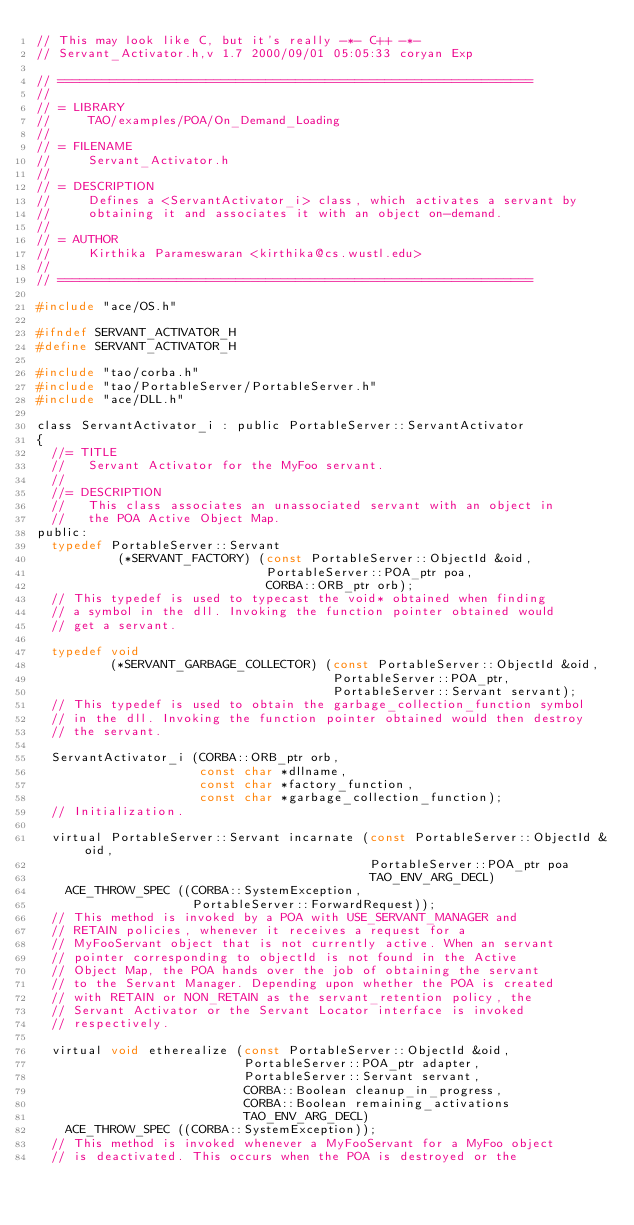Convert code to text. <code><loc_0><loc_0><loc_500><loc_500><_C_>// This may look like C, but it's really -*- C++ -*-
// Servant_Activator.h,v 1.7 2000/09/01 05:05:33 coryan Exp

// ================================================================
//
// = LIBRARY
//     TAO/examples/POA/On_Demand_Loading
//
// = FILENAME
//     Servant_Activator.h
//
// = DESCRIPTION
//     Defines a <ServantActivator_i> class, which activates a servant by
//     obtaining it and associates it with an object on-demand.
//
// = AUTHOR
//     Kirthika Parameswaran <kirthika@cs.wustl.edu>
//
// ================================================================

#include "ace/OS.h"

#ifndef SERVANT_ACTIVATOR_H
#define SERVANT_ACTIVATOR_H

#include "tao/corba.h"
#include "tao/PortableServer/PortableServer.h"
#include "ace/DLL.h"

class ServantActivator_i : public PortableServer::ServantActivator
{
  //= TITLE
  //   Servant Activator for the MyFoo servant.
  //
  //= DESCRIPTION
  //   This class associates an unassociated servant with an object in
  //   the POA Active Object Map.
public:
  typedef PortableServer::Servant
           (*SERVANT_FACTORY) (const PortableServer::ObjectId &oid,
                               PortableServer::POA_ptr poa,
                               CORBA::ORB_ptr orb);
  // This typedef is used to typecast the void* obtained when finding
  // a symbol in the dll. Invoking the function pointer obtained would
  // get a servant.

  typedef void
          (*SERVANT_GARBAGE_COLLECTOR) (const PortableServer::ObjectId &oid,
                                        PortableServer::POA_ptr,
                                        PortableServer::Servant servant);
  // This typedef is used to obtain the garbage_collection_function symbol
  // in the dll. Invoking the function pointer obtained would then destroy
  // the servant.

  ServantActivator_i (CORBA::ORB_ptr orb,
                      const char *dllname,
                      const char *factory_function,
                      const char *garbage_collection_function);
  // Initialization.

  virtual PortableServer::Servant incarnate (const PortableServer::ObjectId &oid,
                                             PortableServer::POA_ptr poa
                                             TAO_ENV_ARG_DECL)
    ACE_THROW_SPEC ((CORBA::SystemException,
                     PortableServer::ForwardRequest));
  // This method is invoked by a POA with USE_SERVANT_MANAGER and
  // RETAIN policies, whenever it receives a request for a
  // MyFooServant object that is not currently active. When an servant
  // pointer corresponding to objectId is not found in the Active
  // Object Map, the POA hands over the job of obtaining the servant
  // to the Servant Manager. Depending upon whether the POA is created
  // with RETAIN or NON_RETAIN as the servant_retention policy, the
  // Servant Activator or the Servant Locator interface is invoked
  // respectively.

  virtual void etherealize (const PortableServer::ObjectId &oid,
                            PortableServer::POA_ptr adapter,
                            PortableServer::Servant servant,
                            CORBA::Boolean cleanup_in_progress,
                            CORBA::Boolean remaining_activations
                            TAO_ENV_ARG_DECL)
    ACE_THROW_SPEC ((CORBA::SystemException));
  // This method is invoked whenever a MyFooServant for a MyFoo object
  // is deactivated. This occurs when the POA is destroyed or the</code> 